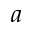Convert formula to latex. <formula><loc_0><loc_0><loc_500><loc_500>a</formula> 